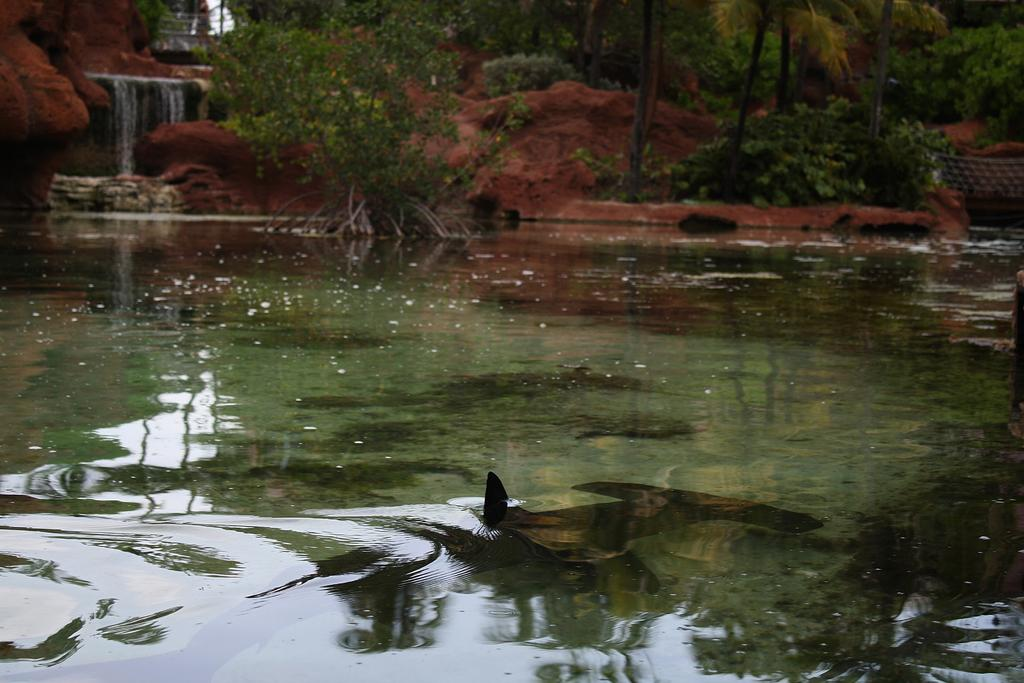What is the primary element in the image? There is water in the image. What can be seen in the water? There are fish in the water. What type of natural environment is visible in the background of the image? There are trees and a small waterfall in the background of the image. What type of terrain is present in the background of the image? Soil is present in the background of the image. What brand of toothpaste is being advertised in the image? There is no toothpaste or advertisement present in the image. Can you tell me how many people are in the group shown in the image? There is no group of people present in the image. 